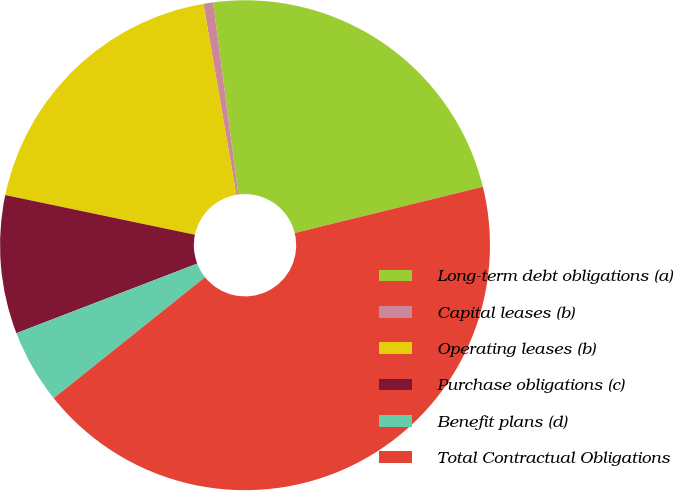Convert chart to OTSL. <chart><loc_0><loc_0><loc_500><loc_500><pie_chart><fcel>Long-term debt obligations (a)<fcel>Capital leases (b)<fcel>Operating leases (b)<fcel>Purchase obligations (c)<fcel>Benefit plans (d)<fcel>Total Contractual Obligations<nl><fcel>23.24%<fcel>0.64%<fcel>19.0%<fcel>9.13%<fcel>4.89%<fcel>43.1%<nl></chart> 